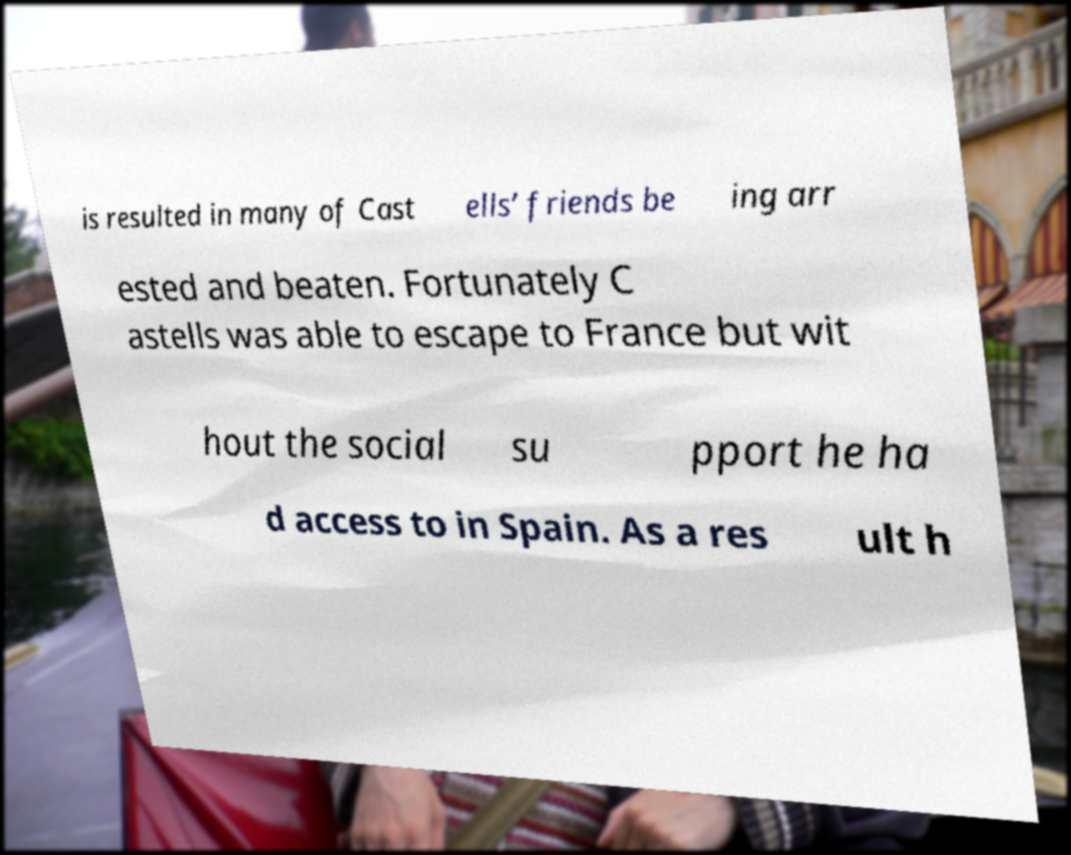Please read and relay the text visible in this image. What does it say? is resulted in many of Cast ells’ friends be ing arr ested and beaten. Fortunately C astells was able to escape to France but wit hout the social su pport he ha d access to in Spain. As a res ult h 